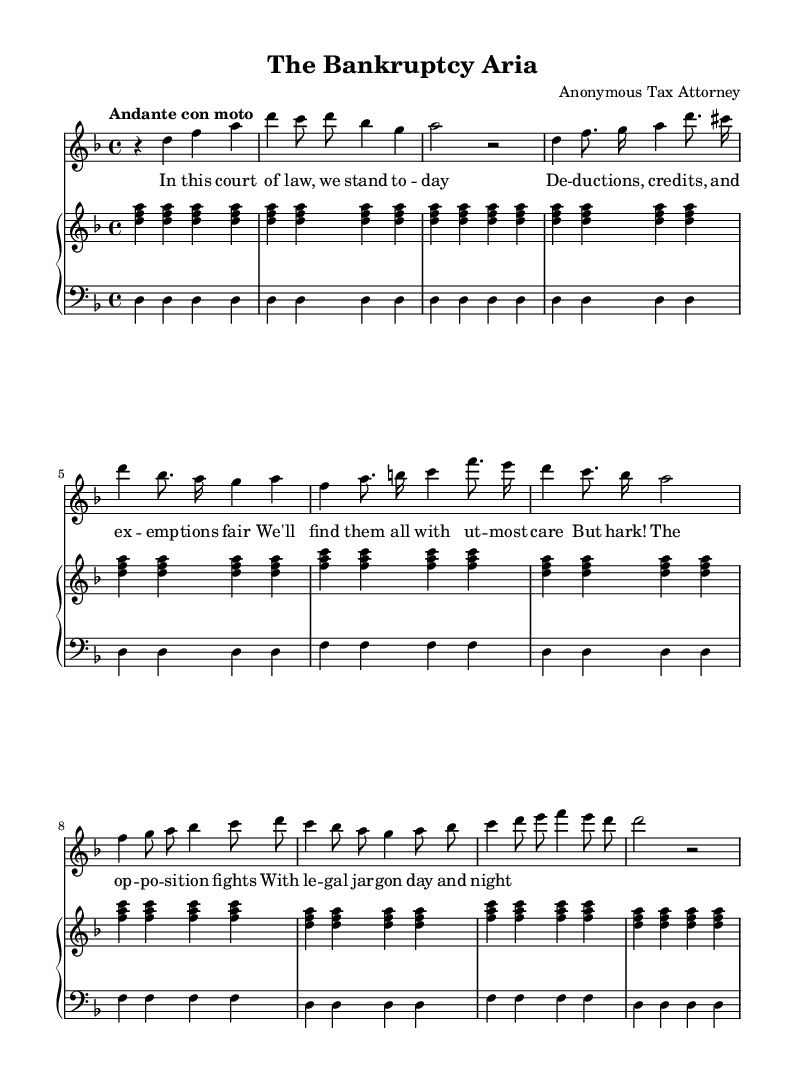What is the key signature of this music? The key signature indicated at the beginning of the score shows two flats, which corresponds to the key of D minor.
Answer: D minor What is the time signature of this music? The time signature shows a 4/4 notation, which means there are four beats in each measure and the quarter note gets one beat.
Answer: 4/4 What is the tempo marking of the piece? The score indicates "Andante con moto" as the tempo, which means a moderately slow tempo with a slight movement.
Answer: Andante con moto How many verses are included in the lyrics? The lyrics consist of one recitative followed by two sections of an aria, which totals three distinct lyrical sections.
Answer: Three In what format is the accompaniment written? The accompaniment consists of a simplified piano arrangement split between treble and bass staves, indicating harmony and support for the vocal line.
Answer: Piano accompaniment What type of legal themes are present in the lyrics? The lyrics refer to deductions, credits, exemptions, and opposition, which reflects themes related to taxation and legal negotiations.
Answer: Taxation and legal negotiations 